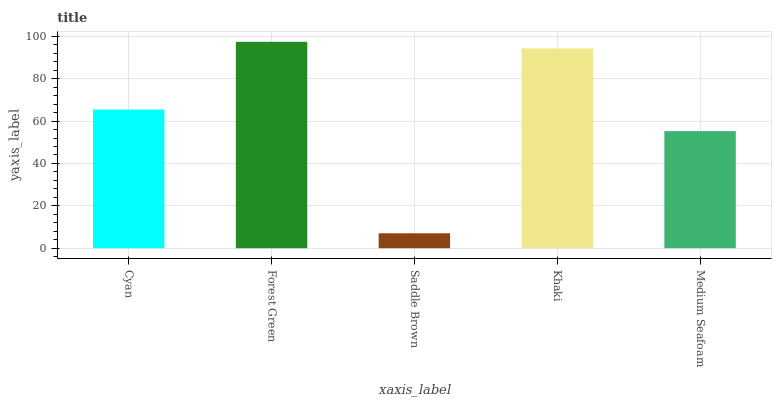Is Saddle Brown the minimum?
Answer yes or no. Yes. Is Forest Green the maximum?
Answer yes or no. Yes. Is Forest Green the minimum?
Answer yes or no. No. Is Saddle Brown the maximum?
Answer yes or no. No. Is Forest Green greater than Saddle Brown?
Answer yes or no. Yes. Is Saddle Brown less than Forest Green?
Answer yes or no. Yes. Is Saddle Brown greater than Forest Green?
Answer yes or no. No. Is Forest Green less than Saddle Brown?
Answer yes or no. No. Is Cyan the high median?
Answer yes or no. Yes. Is Cyan the low median?
Answer yes or no. Yes. Is Forest Green the high median?
Answer yes or no. No. Is Medium Seafoam the low median?
Answer yes or no. No. 